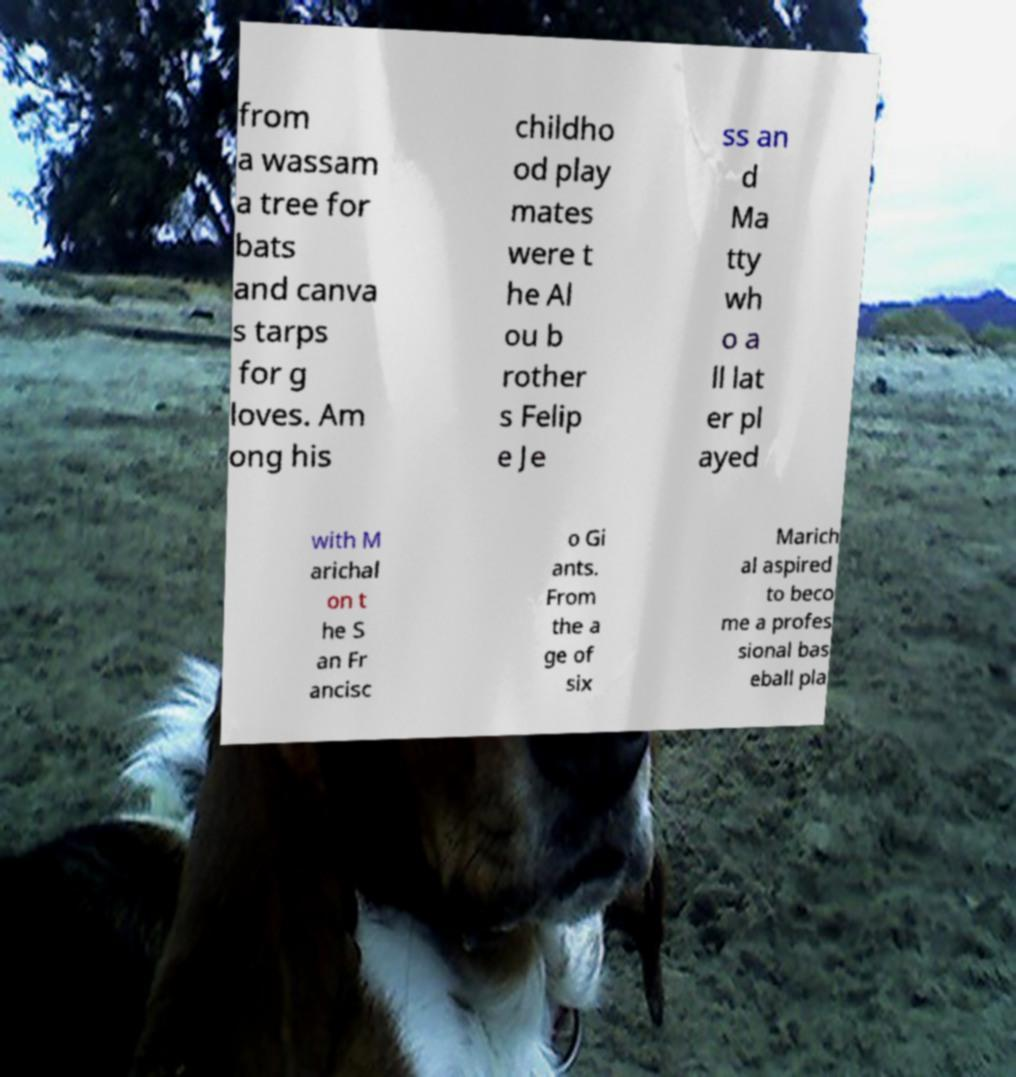There's text embedded in this image that I need extracted. Can you transcribe it verbatim? from a wassam a tree for bats and canva s tarps for g loves. Am ong his childho od play mates were t he Al ou b rother s Felip e Je ss an d Ma tty wh o a ll lat er pl ayed with M arichal on t he S an Fr ancisc o Gi ants. From the a ge of six Marich al aspired to beco me a profes sional bas eball pla 